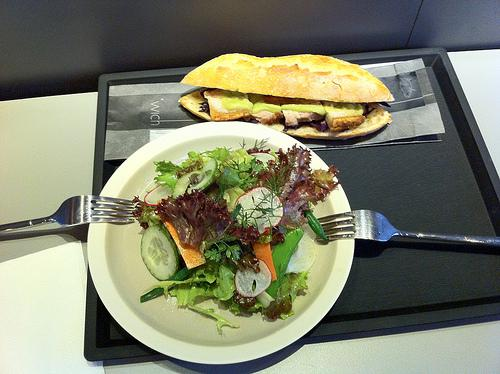Question: what is to the left of the plate?
Choices:
A. A sandwich.
B. Fries.
C. Fruit.
D. A salad.
Answer with the letter. Answer: A Question: who is looking at this tray with food on it?
Choices:
A. The photographer.
B. The child.
C. The mother.
D. The man.
Answer with the letter. Answer: A Question: where are the forks?
Choices:
A. Resting, at either end of the plate.
B. In the dishwasher.
C. In the sink.
D. In the drawer.
Answer with the letter. Answer: A Question: why is there dark green along the edges of the cucumber slices?
Choices:
A. Because they missed some skin while peeling them.
B. Because they were left in the fridge too long.
C. Because that's how the chef cuts them.
D. Because the skin has been left on.
Answer with the letter. Answer: D 